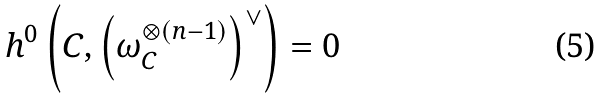Convert formula to latex. <formula><loc_0><loc_0><loc_500><loc_500>h ^ { 0 } \left ( C , \left ( \omega _ { C } ^ { \otimes ( n - 1 ) } \right ) ^ { \vee } \right ) = 0</formula> 